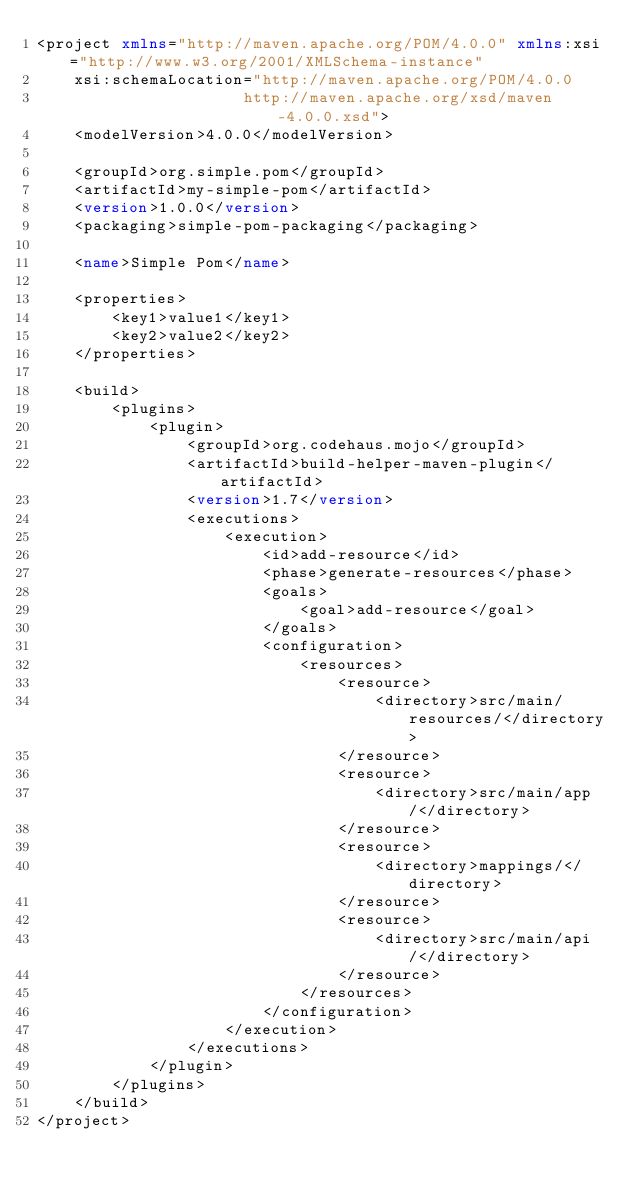Convert code to text. <code><loc_0><loc_0><loc_500><loc_500><_XML_><project xmlns="http://maven.apache.org/POM/4.0.0" xmlns:xsi="http://www.w3.org/2001/XMLSchema-instance"
    xsi:schemaLocation="http://maven.apache.org/POM/4.0.0
                      http://maven.apache.org/xsd/maven-4.0.0.xsd">
    <modelVersion>4.0.0</modelVersion>

    <groupId>org.simple.pom</groupId>
    <artifactId>my-simple-pom</artifactId>
    <version>1.0.0</version>
    <packaging>simple-pom-packaging</packaging>

    <name>Simple Pom</name>

    <properties>
        <key1>value1</key1>
        <key2>value2</key2>
    </properties>

    <build>
        <plugins>
            <plugin>
                <groupId>org.codehaus.mojo</groupId>
                <artifactId>build-helper-maven-plugin</artifactId>
                <version>1.7</version>
                <executions>
                    <execution>
                        <id>add-resource</id>
                        <phase>generate-resources</phase>
                        <goals>
                            <goal>add-resource</goal>
                        </goals>
                        <configuration>
                            <resources>
                                <resource>
                                    <directory>src/main/resources/</directory>
                                </resource>
                                <resource>
                                    <directory>src/main/app/</directory>
                                </resource>
                                <resource>
                                    <directory>mappings/</directory>
                                </resource>
                                <resource>
                                    <directory>src/main/api/</directory>
                                </resource>
                            </resources>
                        </configuration>
                    </execution>
                </executions>
            </plugin>
        </plugins>
    </build>
</project></code> 